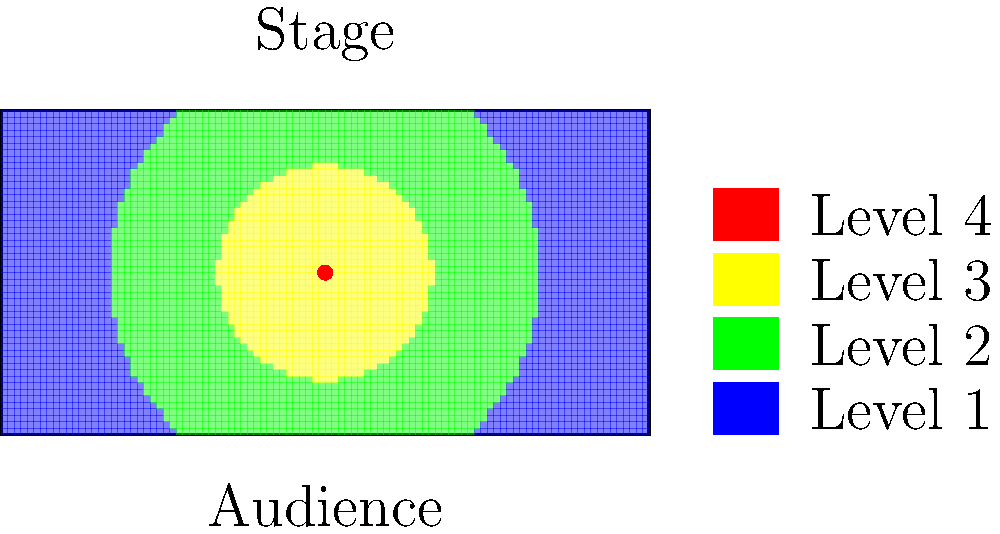Based on the heatmap overlaid on the stage diagram, which area of the stage appears to receive the highest level of attention from the audience during a magic show? To answer this question, we need to analyze the heatmap overlaid on the stage diagram:

1. The heatmap uses colors to represent different levels of attention, with red indicating the highest level of attention and blue indicating the lowest.

2. The legend on the right side of the diagram shows four levels of attention, from Level 1 (lowest) to Level 4 (highest).

3. Examining the stage area, we can see that the colors vary from blue at the edges to red in the center.

4. The red dot in the center of the stage likely represents the position of the magician.

5. The area immediately surrounding the red dot (magician's position) has the most intense red color, indicating the highest level of attention.

6. This concentration of attention makes sense psychologically, as spectators tend to focus on the magician and their immediate surroundings during a performance.

7. The attention level gradually decreases as we move away from the center, transitioning through yellow and green to blue at the edges of the stage.

Therefore, based on this heatmap, the center of the stage where the magician is likely to be positioned receives the highest level of attention from the audience during a magic show.
Answer: Center of the stage 